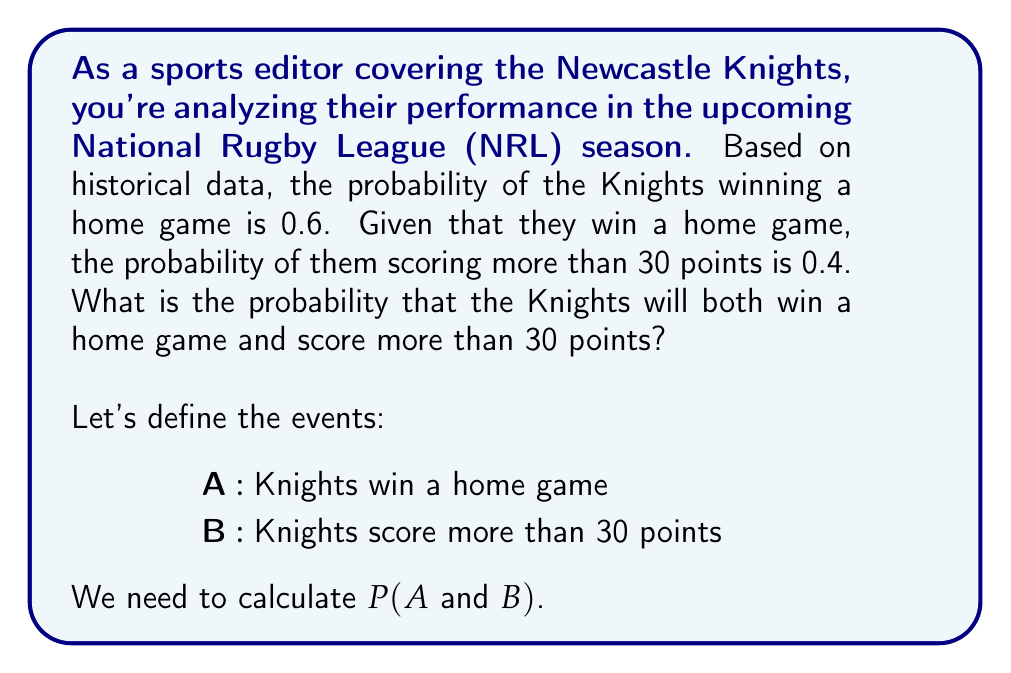Teach me how to tackle this problem. To solve this problem, we'll use the conditional probability formula:

$$P(A \text{ and } B) = P(A) \cdot P(B|A)$$

Where:
$P(A)$ is the probability of the Knights winning a home game
$P(B|A)$ is the probability of scoring more than 30 points given that they win a home game

We're given:
$P(A) = 0.6$
$P(B|A) = 0.4$

Now, let's substitute these values into the formula:

$$P(A \text{ and } B) = 0.6 \cdot 0.4$$

Calculating:
$$P(A \text{ and } B) = 0.24$$

Therefore, the probability that the Newcastle Knights will both win a home game and score more than 30 points is 0.24 or 24%.
Answer: 0.24 